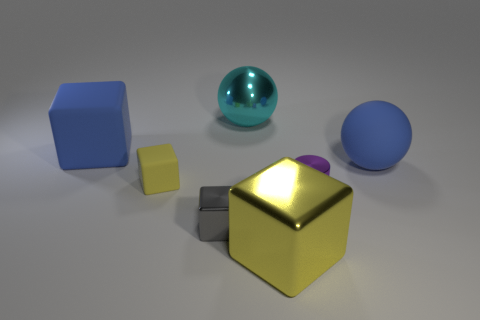What is the size of the metallic cube that is the same color as the tiny rubber cube?
Offer a very short reply. Large. What number of other objects are the same size as the shiny sphere?
Offer a very short reply. 3. Is the color of the cube that is behind the small yellow rubber thing the same as the matte sphere?
Your response must be concise. Yes. Are there more tiny metallic objects that are right of the cyan object than big blue metal cylinders?
Keep it short and to the point. Yes. Are there any other things that have the same color as the big metallic cube?
Your answer should be compact. Yes. There is a blue thing that is to the left of the block that is in front of the gray metallic cube; what shape is it?
Ensure brevity in your answer.  Cube. Is the number of blue blocks greater than the number of tiny red matte blocks?
Give a very brief answer. Yes. How many small metallic things are behind the small gray thing and to the left of the small shiny cylinder?
Provide a short and direct response. 0. How many purple shiny cylinders are to the right of the big blue object on the right side of the small yellow block?
Provide a short and direct response. 0. How many things are either yellow matte things that are left of the cyan sphere or yellow cubes on the left side of the large metal cube?
Provide a succinct answer. 1. 